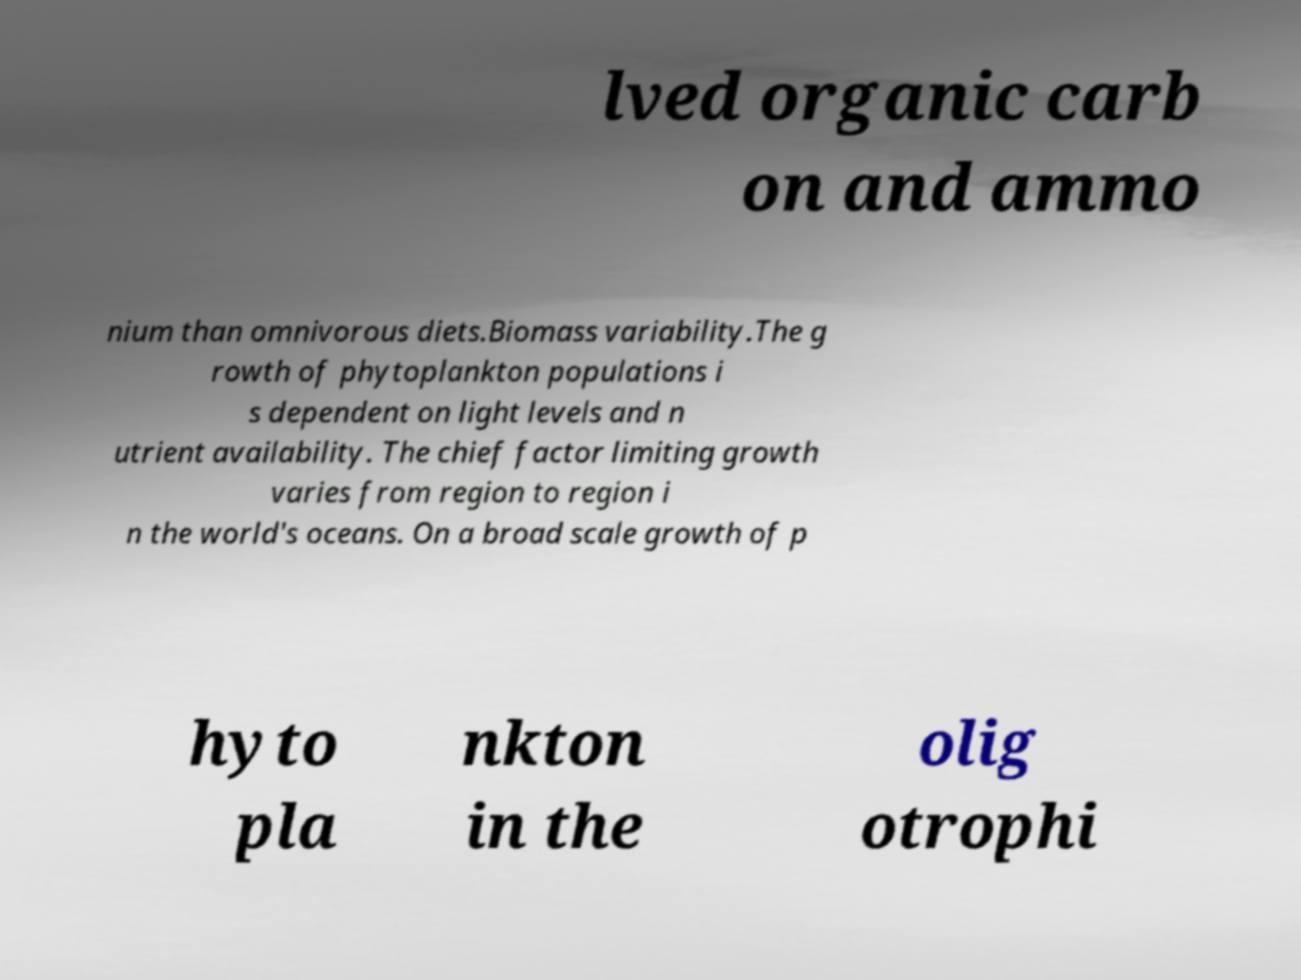Can you accurately transcribe the text from the provided image for me? lved organic carb on and ammo nium than omnivorous diets.Biomass variability.The g rowth of phytoplankton populations i s dependent on light levels and n utrient availability. The chief factor limiting growth varies from region to region i n the world's oceans. On a broad scale growth of p hyto pla nkton in the olig otrophi 